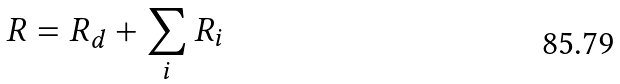Convert formula to latex. <formula><loc_0><loc_0><loc_500><loc_500>R = R _ { d } + \sum _ { i } { R _ { i } }</formula> 